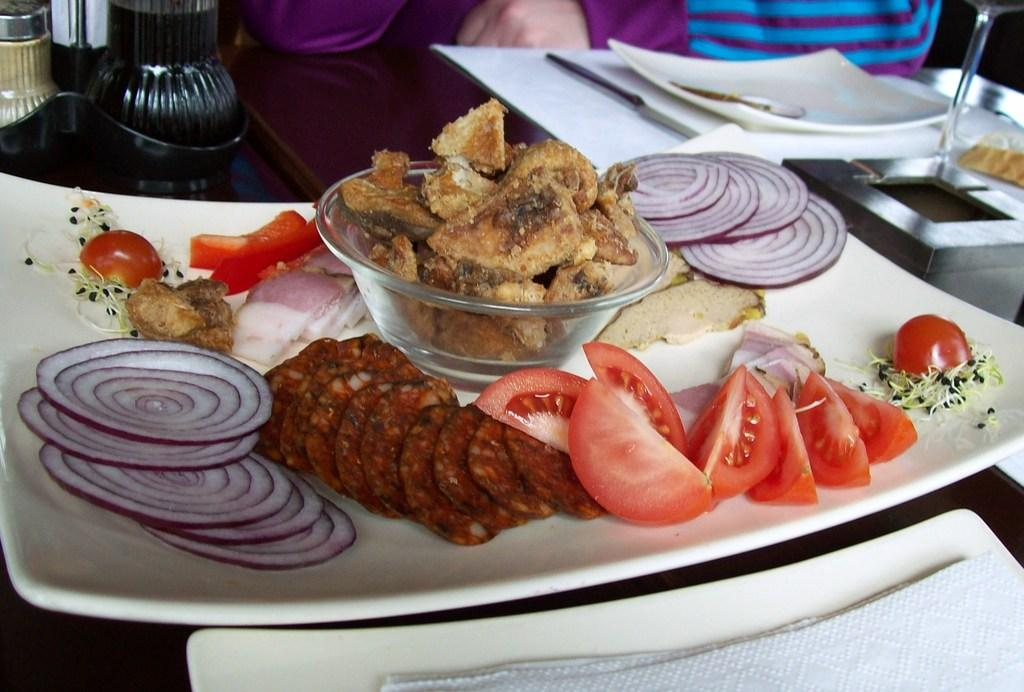What type of food is in the plate in the image? There is food in a plate in the image, but the specific type of food is not mentioned. What type of food is in the bowl in the image? There is food in a bowl in the image, but the specific type of food is not mentioned. What type of food is visible in the image? There are veggies visible in the image. How many plates with food are there in the image? There is another plate with food in the image, so there are two plates with food in total. What utensil is present in the image? A knife is present in the image. What might be used for cleaning or wiping in the image? Napkins are visible in the image for cleaning or wiping. Where are the food, plates, and utensils located in the image? The food, plates, and utensils are on a table in the image. What type of wire is used to hold the truck in the image? There is no wire or truck present in the image; it features food, plates, utensils, veggies, a knife, and napkins on a table. 